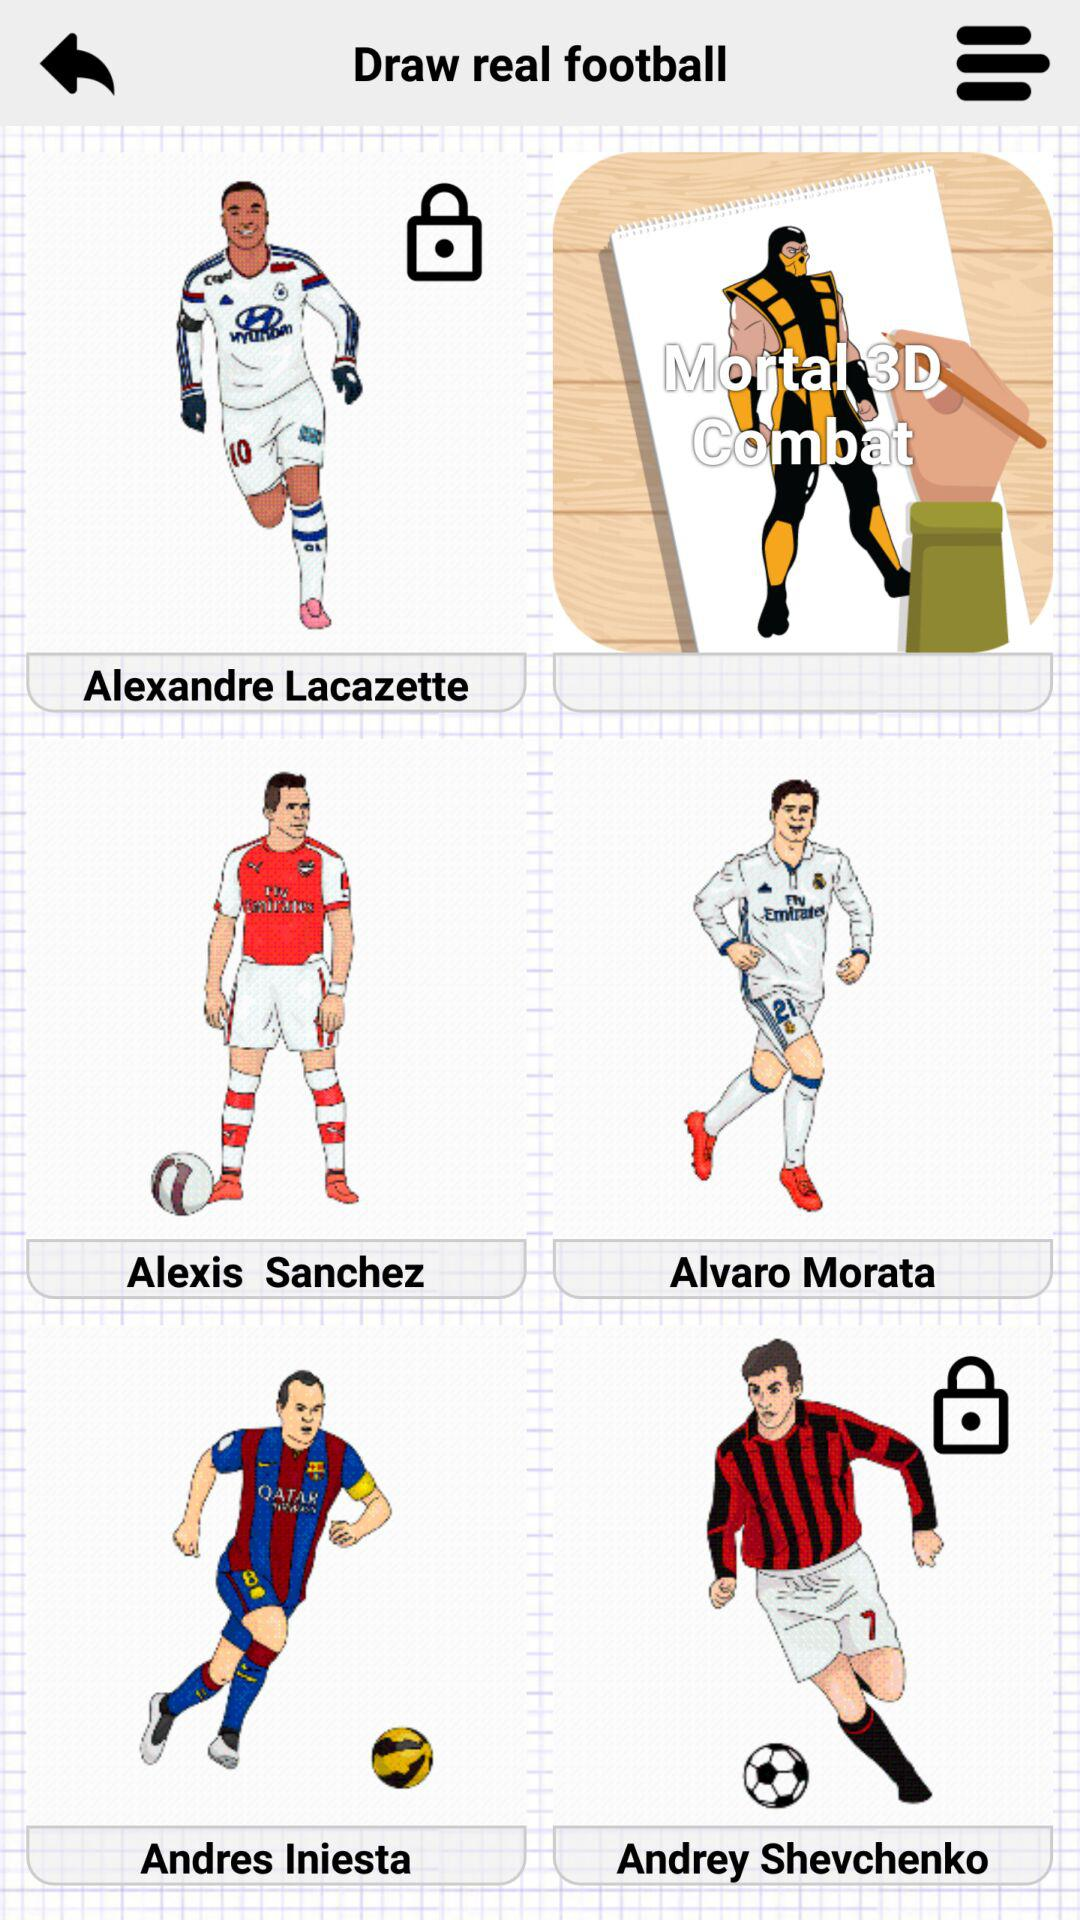What are the names of the players? The names of the players are "Alexandre Lacazette", "Alexis Sanchez", "Alvaro Morata", "Andres Iniesta", and "Andrey Shevchenko". 